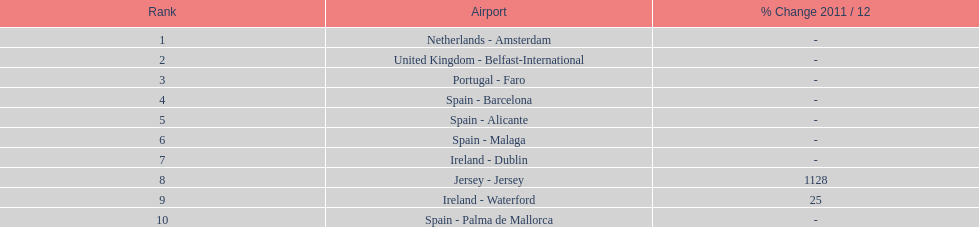Comparing the airports in the netherlands (amsterdam) and spain (palma de mallorca), what is the disparity in the volume of passengers they manage? 77,631. 